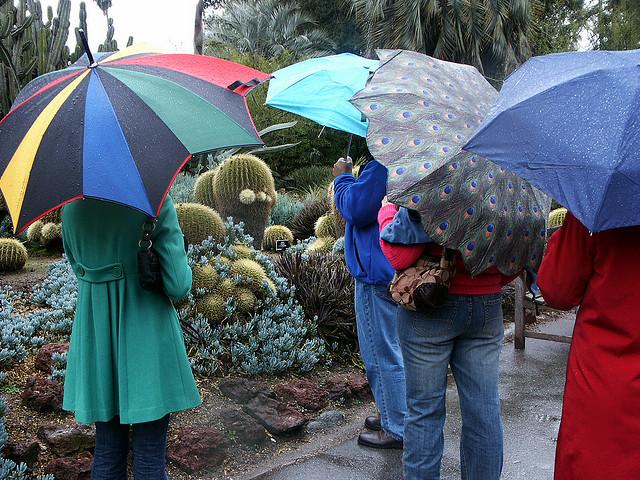Are the plants sharp?
Short answer required. Yes. Is it raining?
Write a very short answer. Yes. Are the people in the wilderness?
Short answer required. No. 